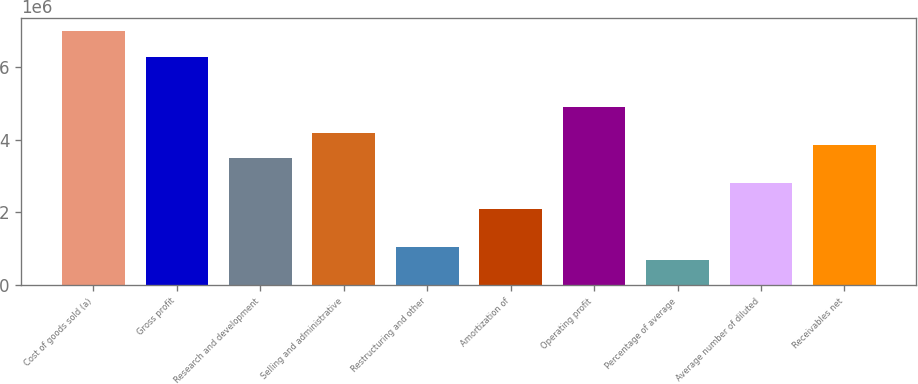Convert chart to OTSL. <chart><loc_0><loc_0><loc_500><loc_500><bar_chart><fcel>Cost of goods sold (a)<fcel>Gross profit<fcel>Research and development<fcel>Selling and administrative<fcel>Restructuring and other<fcel>Amortization of<fcel>Operating profit<fcel>Percentage of average<fcel>Average number of diluted<fcel>Receivables net<nl><fcel>6.98924e+06<fcel>6.29032e+06<fcel>3.49462e+06<fcel>4.19354e+06<fcel>1.04839e+06<fcel>2.09677e+06<fcel>4.89247e+06<fcel>698926<fcel>2.7957e+06<fcel>3.84408e+06<nl></chart> 